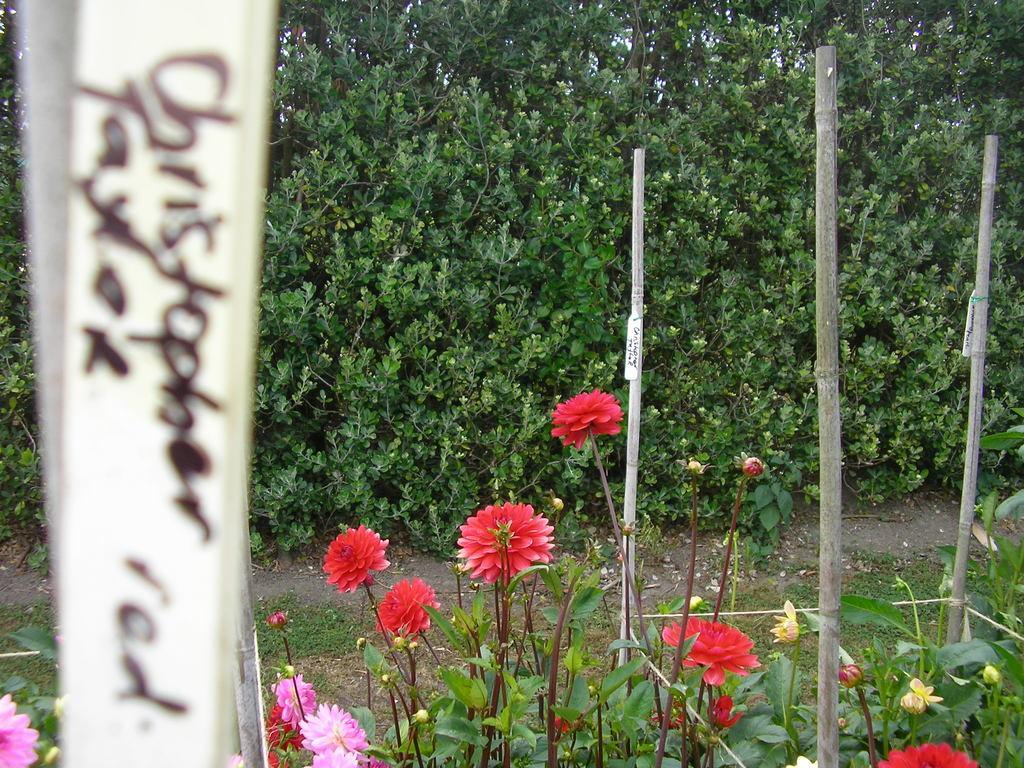Could you give a brief overview of what you see in this image? In the foreground I can see flowering plants, bamboo sticks and trees. This image is taken may be in a farm. 